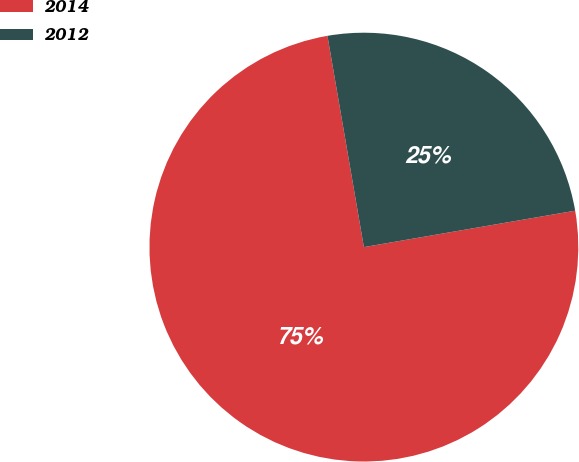Convert chart to OTSL. <chart><loc_0><loc_0><loc_500><loc_500><pie_chart><fcel>2014<fcel>2012<nl><fcel>75.0%<fcel>25.0%<nl></chart> 